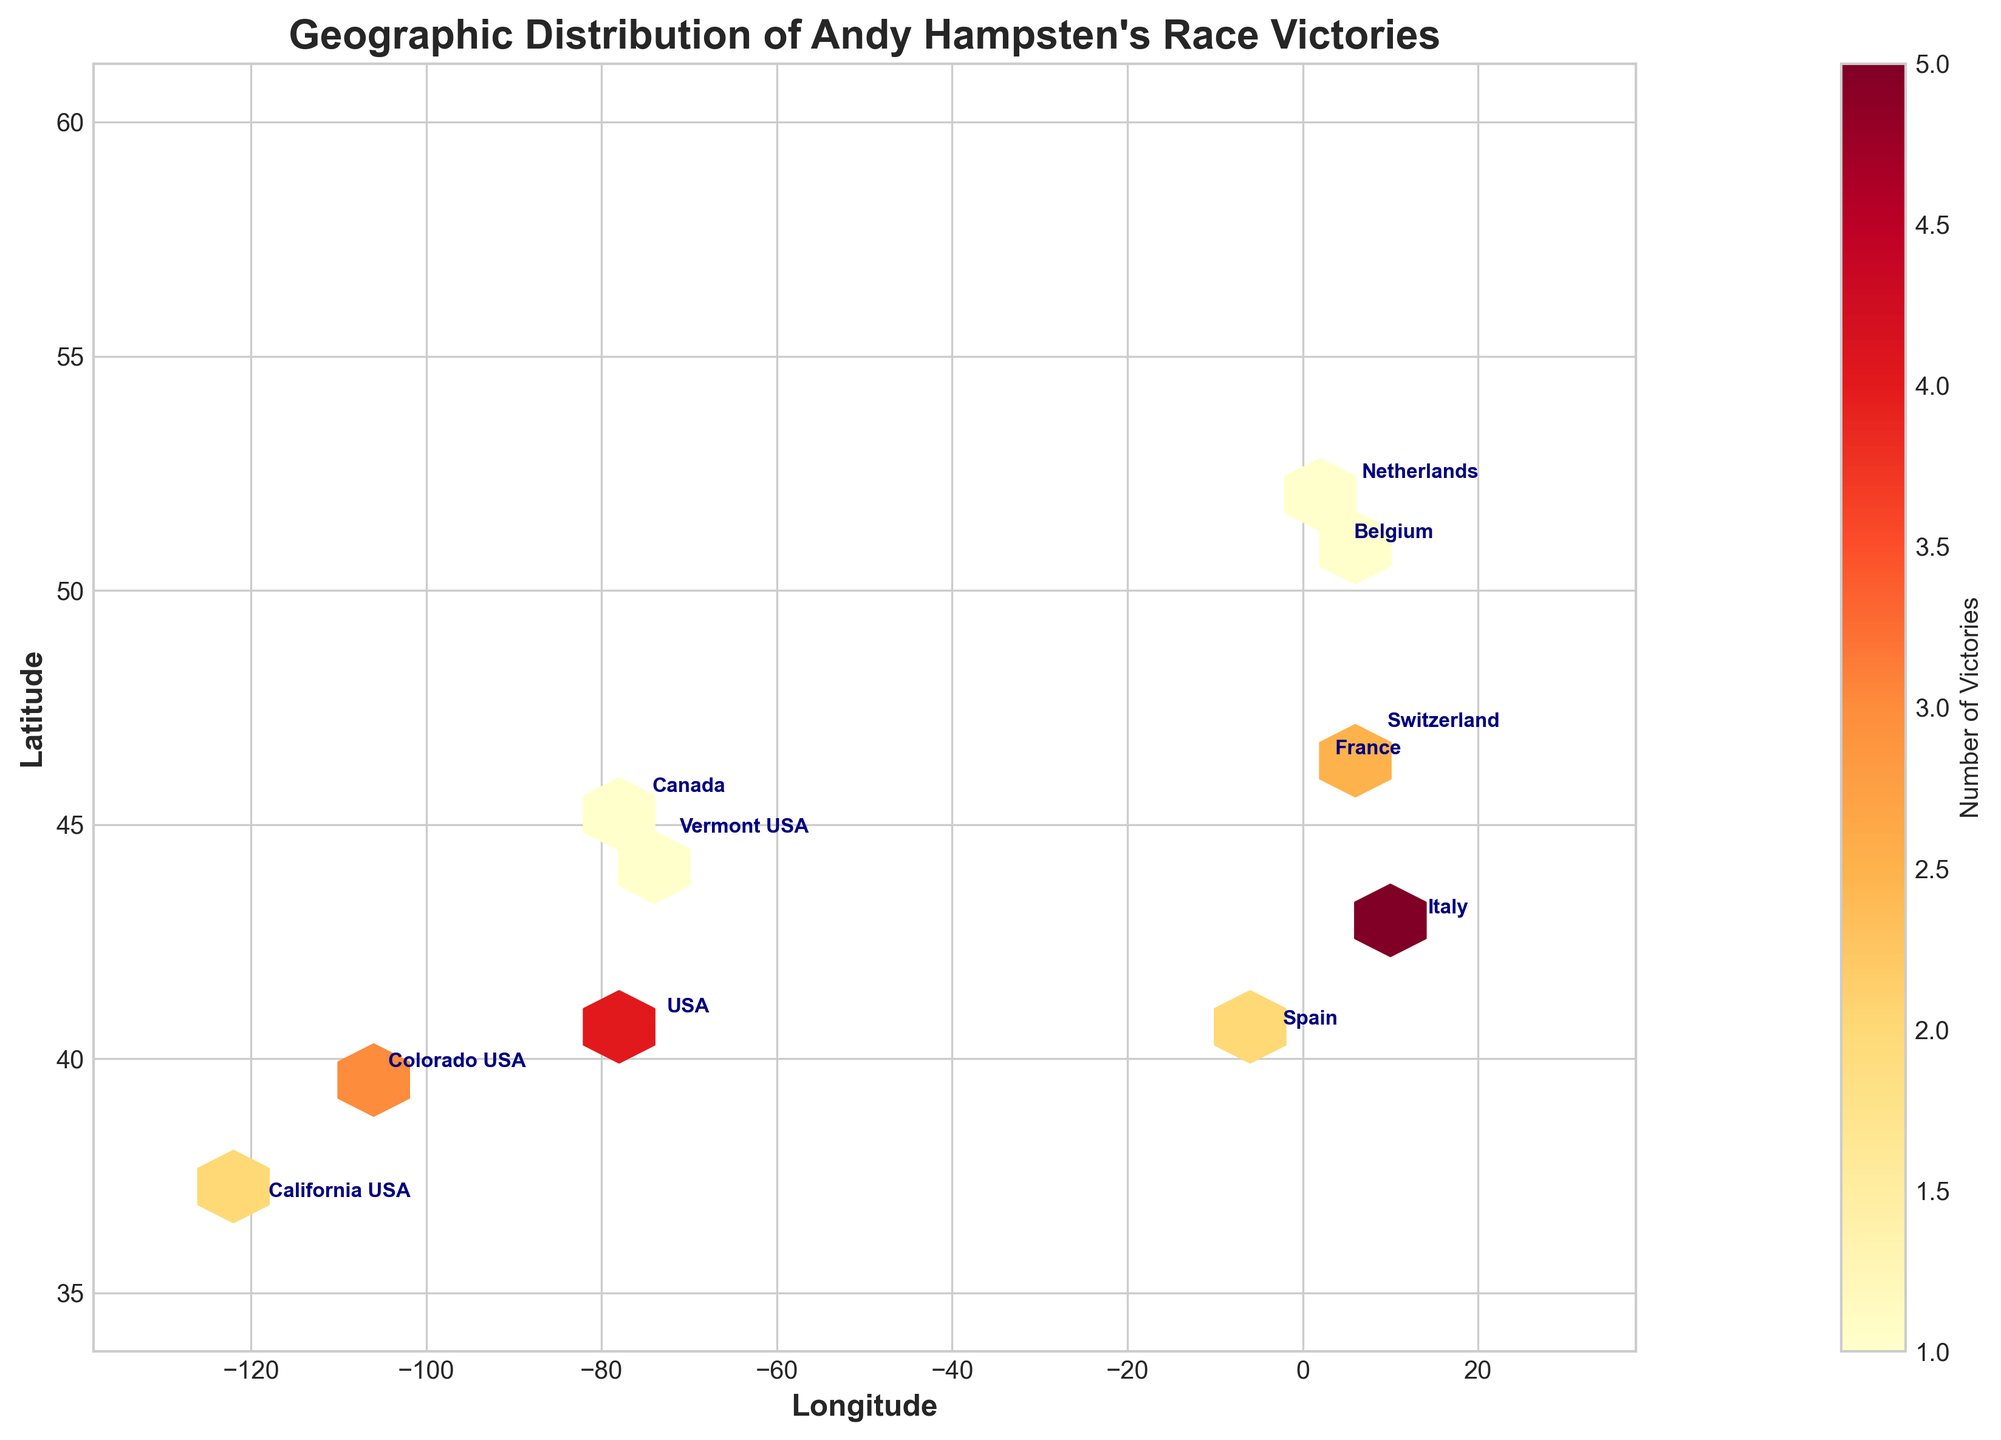Which country has the highest number of victories? Italy. From the plot, Italy is represented with the highest color intensity in the hexbin plot indicating 5 victories.
Answer: Italy What is the title of the hexbin plot? The title is clearly written at the top of the plot.
Answer: Geographic Distribution of Andy Hampsten's Race Victories How many race victories did Hampsten achieve in the USA? The plot shows three labeled locations in the USA: USA (4 victories), Colorado (3 victories), and California (2 victories). Adding these, 4 + 3 + 2 = 9.
Answer: 9 Which region, North America or Europe, has more countries where Hampsten won races? The hexbin plot shows labels for the victories across different countries. In North America, there are the USA and Canada (2 countries). In Europe, there are Italy, France, Switzerland, Spain, Belgium, and Netherlands (6 countries).
Answer: Europe Which countries in Europe did Hampsten win at least one race? All the labeled points in Europe indicate Hampsten's victories: Italy, France, Switzerland, Spain, Belgium, and Netherlands.
Answer: Italy, France, Switzerland, Spain, Belgium, Netherlands What is the range of latitudes used in this plot? By observing the y-axis in the plot, the labeled latitudes range from the minimum around 35 to the maximum around 60.
Answer: 35 to 60 Compare the number of victories in France and Switzerland. Which country has more? The hexbin plot shows France has 3 victories and Switzerland has 2 victories.
Answer: France What color represents the area with the most victories? The color bar shows that the highest number of victories is represented in the darkest shade of red.
Answer: Darkest shade of red How many race locations in North America are annotated on the plot? The plot shows labeled points at USA, Colorado, California, and Vermont in the USA, and one point in Canada. Adding these gives 5 annotations.
Answer: 5 Which location in the USA has the highest number of victories? According to the plot, the location labeled as "USA" (40.7128, -74.0060) indicates 4 victories.
Answer: USA (40.7128, -74.0060) 